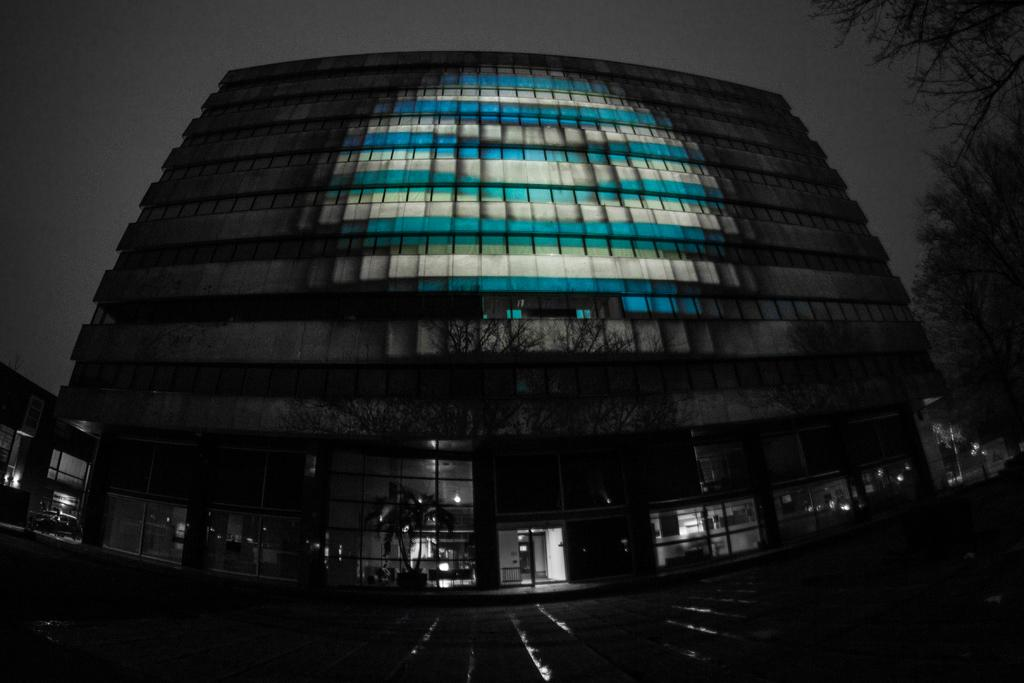What type of structure is present in the image? There is a building in the image. What can be seen on the right side of the image? There are trees on the right side of the image. What is visible at the top of the image? The sky is visible at the top of the image. What type of business is conducted in the building in the image? The provided facts do not mention any specific business or activity taking place in the building, so it cannot be determined from the image. 